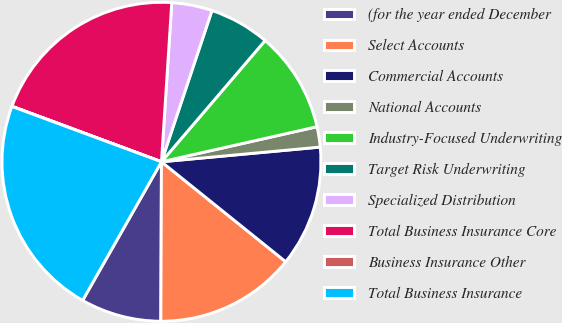Convert chart. <chart><loc_0><loc_0><loc_500><loc_500><pie_chart><fcel>(for the year ended December<fcel>Select Accounts<fcel>Commercial Accounts<fcel>National Accounts<fcel>Industry-Focused Underwriting<fcel>Target Risk Underwriting<fcel>Specialized Distribution<fcel>Total Business Insurance Core<fcel>Business Insurance Other<fcel>Total Business Insurance<nl><fcel>8.17%<fcel>14.28%<fcel>12.25%<fcel>2.06%<fcel>10.21%<fcel>6.13%<fcel>4.1%<fcel>20.37%<fcel>0.02%<fcel>22.41%<nl></chart> 